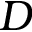Convert formula to latex. <formula><loc_0><loc_0><loc_500><loc_500>D</formula> 